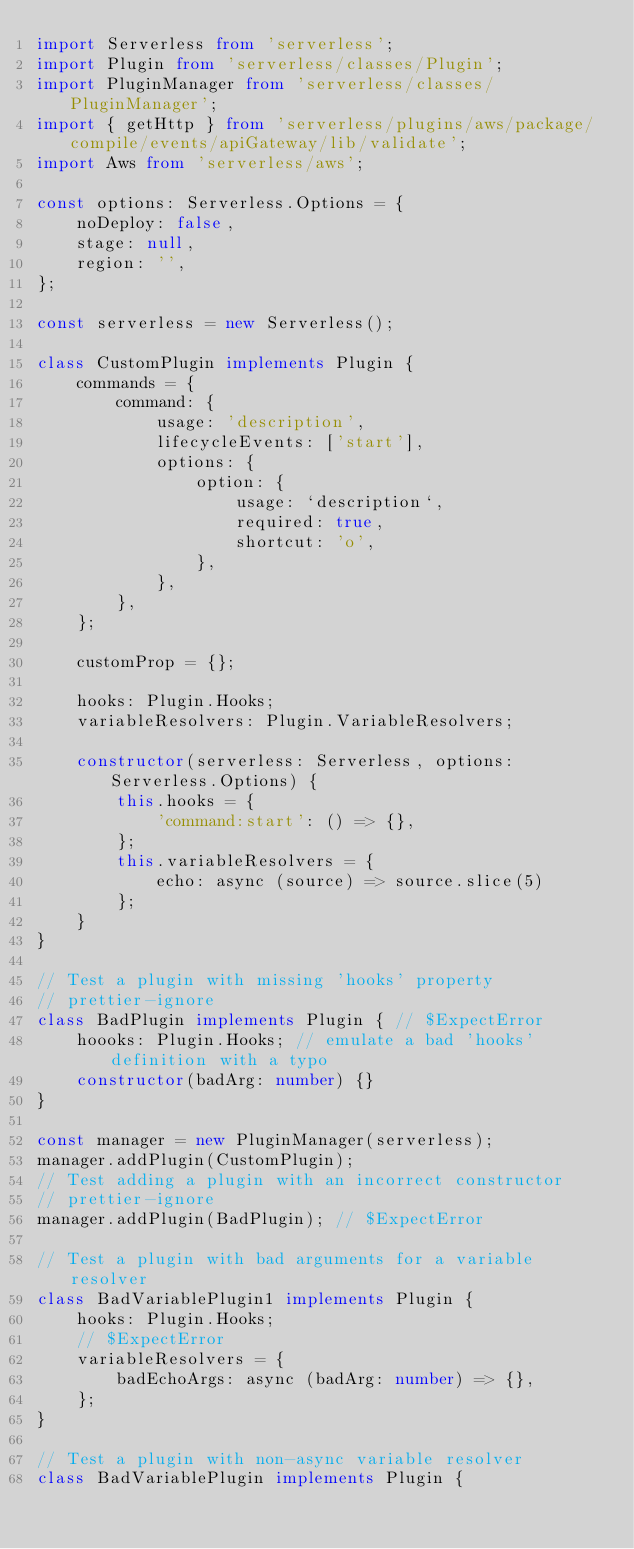Convert code to text. <code><loc_0><loc_0><loc_500><loc_500><_TypeScript_>import Serverless from 'serverless';
import Plugin from 'serverless/classes/Plugin';
import PluginManager from 'serverless/classes/PluginManager';
import { getHttp } from 'serverless/plugins/aws/package/compile/events/apiGateway/lib/validate';
import Aws from 'serverless/aws';

const options: Serverless.Options = {
    noDeploy: false,
    stage: null,
    region: '',
};

const serverless = new Serverless();

class CustomPlugin implements Plugin {
    commands = {
        command: {
            usage: 'description',
            lifecycleEvents: ['start'],
            options: {
                option: {
                    usage: `description`,
                    required: true,
                    shortcut: 'o',
                },
            },
        },
    };

    customProp = {};

    hooks: Plugin.Hooks;
    variableResolvers: Plugin.VariableResolvers;

    constructor(serverless: Serverless, options: Serverless.Options) {
        this.hooks = {
            'command:start': () => {},
        };
        this.variableResolvers = {
            echo: async (source) => source.slice(5)
        };
    }
}

// Test a plugin with missing 'hooks' property
// prettier-ignore
class BadPlugin implements Plugin { // $ExpectError
    hoooks: Plugin.Hooks; // emulate a bad 'hooks' definition with a typo
    constructor(badArg: number) {}
}

const manager = new PluginManager(serverless);
manager.addPlugin(CustomPlugin);
// Test adding a plugin with an incorrect constructor
// prettier-ignore
manager.addPlugin(BadPlugin); // $ExpectError

// Test a plugin with bad arguments for a variable resolver
class BadVariablePlugin1 implements Plugin {
    hooks: Plugin.Hooks;
    // $ExpectError
    variableResolvers = {
        badEchoArgs: async (badArg: number) => {},
    };
}

// Test a plugin with non-async variable resolver
class BadVariablePlugin implements Plugin {</code> 